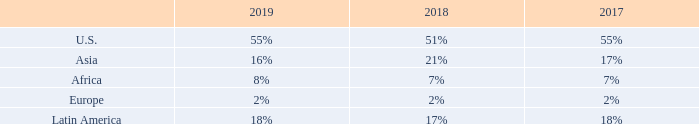Our property business includes the operation of communications sites and managed networks, the leasing of property interests, and, in select markets, the operation of fiber and the provision of backup power through shared generators. Our presence in a number of markets at different relative stages of wireless development provides us with significant diversification and long-term growth potential. Our property segments accounted for the following percentage of consolidated total revenue for the years ended December 31,:
Communications Sites. Approximately 95%, 96% and 97% of revenue in our property segments was attributable to our communications sites, excluding DAS networks, for the years ended December 31, 2019, 2018 and 2017, respectively.
We lease space on our communications sites to tenants providing a diverse range of communications services, including cellular voice and data, broadcasting, mobile video and a number of other applications. In addition, in many of our international markets, we receive pass-through revenue from our tenants to cover certain costs, including power and fuel costs and ground rent. Our top tenants by revenue for each region are as follows for the year ended December 31, 2019: • U.S.: AT&T Inc. (“AT&T”); Verizon Wireless; T-Mobile US, Inc. (“T-Mobile”); and Sprint Corporation (“Sprint”) accounted for an aggregate of 89% of U.S. property segment revenue. T-Mobile and Sprint have announced plans to merge in 2020. • Asia: Vodafone Idea Limited; Bharti Airtel Limited (“Airtel”); and Reliance Jio accounted for an aggregate of 83% of Asia property segment revenue. • Africa: MTN Group Limited (“MTN”); and Airtel accounted for an aggregate of 74% of Africa property segment revenue. • Europe: Telefónica S.A (“Telefónica”); Bouygues; and Free accounted for an aggregate of 70% of Europe property segment revenue. • Latin America: Telefónica; AT&T; and América Móvil accounted for an aggregate of 58% of Latin America property segment revenue.
What was the approximate percentage of revenue in the company's property segments were attributable to their communication sites in 2018? 96%. How many percent of total revenue in 2019 was accounted for by property segments in the U.S.? 55%. How many percent of total revenue in 2018 was accounted for by property segments in Asia? 21%. What is the sum of the three highest contributing property segments in 2017?
Answer scale should be: percent. 55%+18%+17%
Answer: 90. What is the sum of the three least contributing property segments in 2019?
Answer scale should be: percent. 2%+8%+16%
Answer: 26. What was the change in the percentage of total revenue in U.S. between 2018 and 2019?
Answer scale should be: percent. 55%-51%
Answer: 4. 